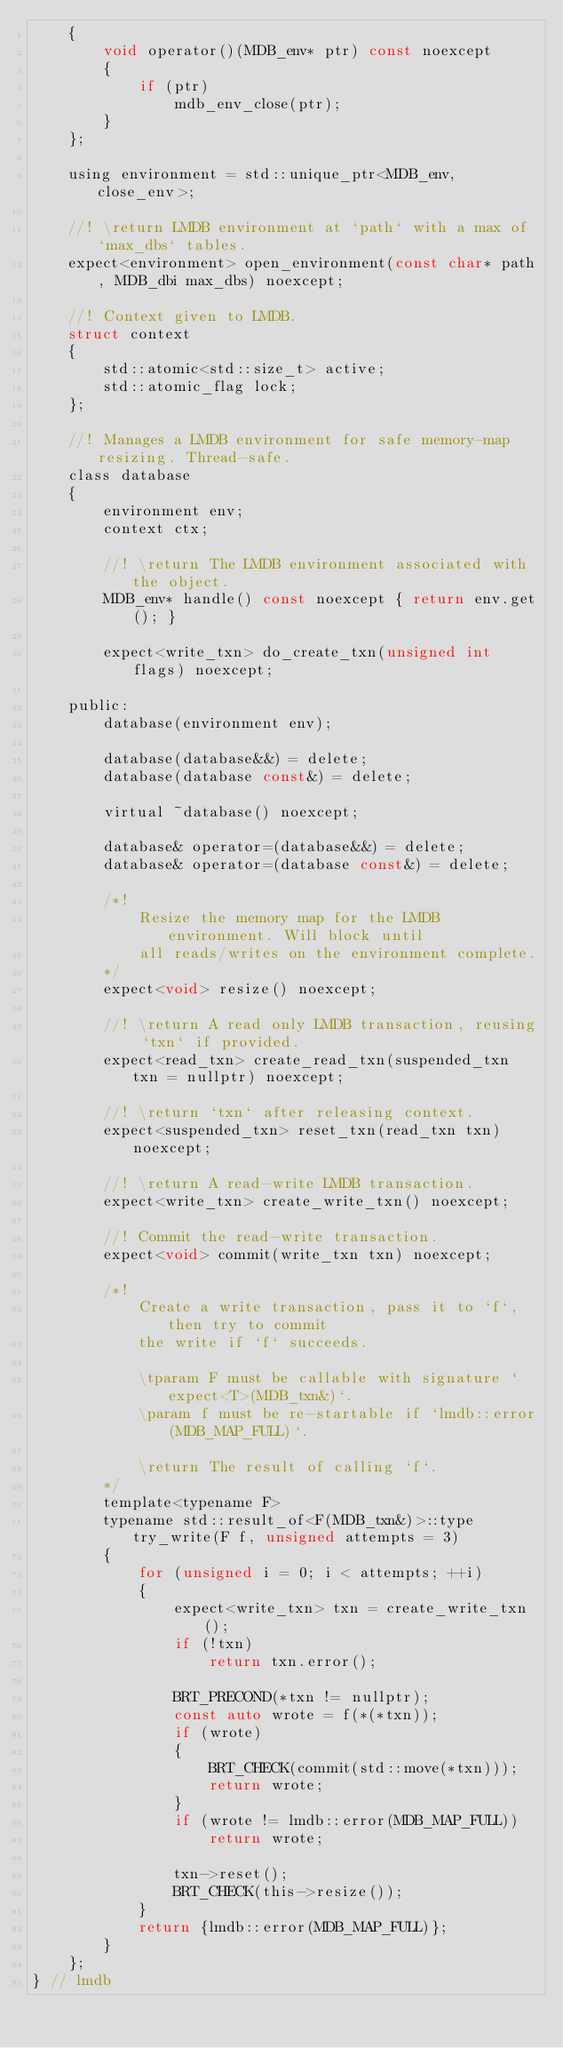Convert code to text. <code><loc_0><loc_0><loc_500><loc_500><_C_>    {
        void operator()(MDB_env* ptr) const noexcept
        {
            if (ptr)
                mdb_env_close(ptr);
        }
    };

    using environment = std::unique_ptr<MDB_env, close_env>;

    //! \return LMDB environment at `path` with a max of `max_dbs` tables.
    expect<environment> open_environment(const char* path, MDB_dbi max_dbs) noexcept;

    //! Context given to LMDB.
    struct context
    {
        std::atomic<std::size_t> active;
        std::atomic_flag lock;
    };

    //! Manages a LMDB environment for safe memory-map resizing. Thread-safe.
    class database
    {
        environment env;
        context ctx;

        //! \return The LMDB environment associated with the object.
        MDB_env* handle() const noexcept { return env.get(); }

        expect<write_txn> do_create_txn(unsigned int flags) noexcept;

    public: 
        database(environment env);

        database(database&&) = delete;
        database(database const&) = delete;

        virtual ~database() noexcept;

        database& operator=(database&&) = delete;
        database& operator=(database const&) = delete;

        /*!
            Resize the memory map for the LMDB environment. Will block until
            all reads/writes on the environment complete.
        */
        expect<void> resize() noexcept;

        //! \return A read only LMDB transaction, reusing `txn` if provided.
        expect<read_txn> create_read_txn(suspended_txn txn = nullptr) noexcept;

        //! \return `txn` after releasing context.
        expect<suspended_txn> reset_txn(read_txn txn) noexcept;

        //! \return A read-write LMDB transaction.
        expect<write_txn> create_write_txn() noexcept;

        //! Commit the read-write transaction.
        expect<void> commit(write_txn txn) noexcept;

        /*!
            Create a write transaction, pass it to `f`, then try to commit
            the write if `f` succeeds.

            \tparam F must be callable with signature `expect<T>(MDB_txn&)`.
            \param f must be re-startable if `lmdb::error(MDB_MAP_FULL)`.

            \return The result of calling `f`.
        */
        template<typename F>
        typename std::result_of<F(MDB_txn&)>::type try_write(F f, unsigned attempts = 3)
        {
            for (unsigned i = 0; i < attempts; ++i)
            {
                expect<write_txn> txn = create_write_txn();
                if (!txn)
                    return txn.error();

                BRT_PRECOND(*txn != nullptr);
                const auto wrote = f(*(*txn));
                if (wrote)
                {
                    BRT_CHECK(commit(std::move(*txn)));
                    return wrote;
                }
                if (wrote != lmdb::error(MDB_MAP_FULL))
                    return wrote;

                txn->reset();
                BRT_CHECK(this->resize());
            }
            return {lmdb::error(MDB_MAP_FULL)};
        }
    };
} // lmdb

</code> 